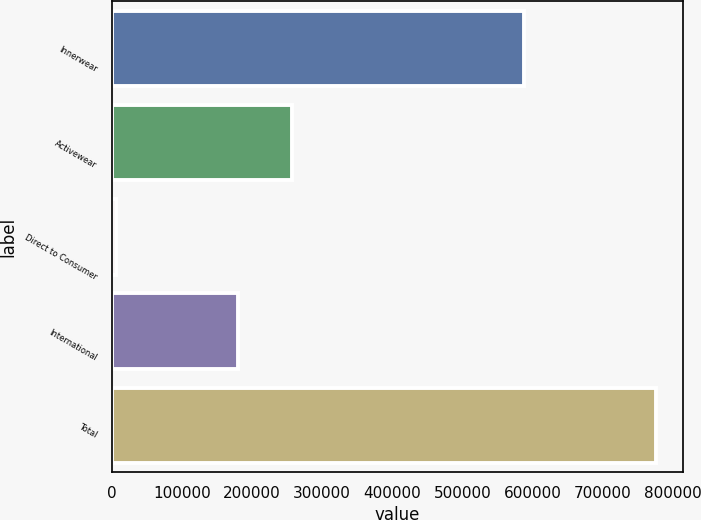Convert chart. <chart><loc_0><loc_0><loc_500><loc_500><bar_chart><fcel>Innerwear<fcel>Activewear<fcel>Direct to Consumer<fcel>International<fcel>Total<nl><fcel>588265<fcel>256926<fcel>5564<fcel>179917<fcel>775649<nl></chart> 